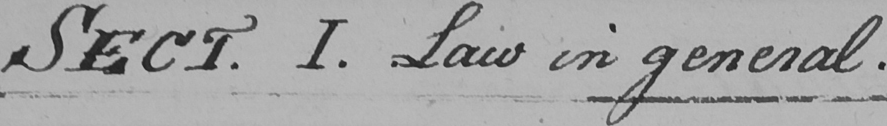Please transcribe the handwritten text in this image. SECT . I . Law in general . 